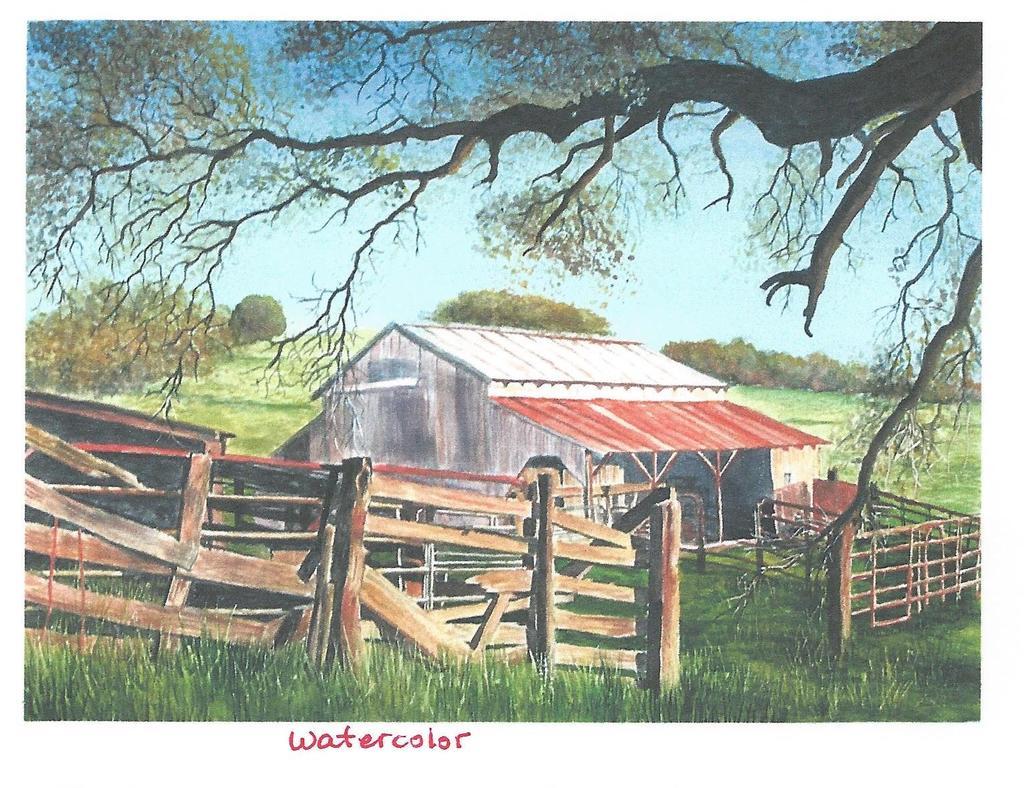What was the image painted with?
Offer a very short reply. Watercolor. 